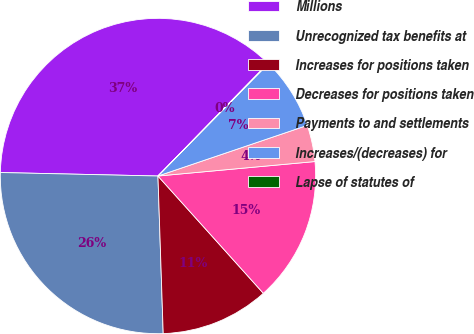<chart> <loc_0><loc_0><loc_500><loc_500><pie_chart><fcel>Millions<fcel>Unrecognized tax benefits at<fcel>Increases for positions taken<fcel>Decreases for positions taken<fcel>Payments to and settlements<fcel>Increases/(decreases) for<fcel>Lapse of statutes of<nl><fcel>36.95%<fcel>25.88%<fcel>11.12%<fcel>14.81%<fcel>3.74%<fcel>7.43%<fcel>0.06%<nl></chart> 